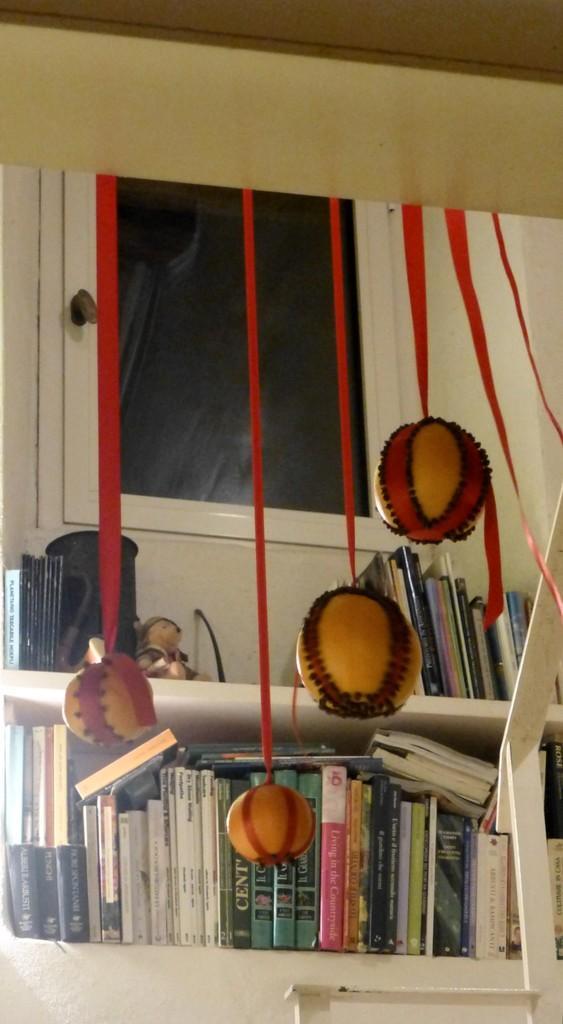Can you describe this image briefly? In the image we can see there are balls which are tied to a rope and hanging from the top. Behind there are books kept in a shelf and on the table top there is a small teddy bear and a CD container is kept. 